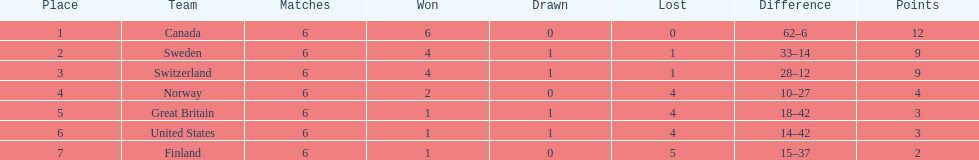What is the number of teams that achieved 6 victories? 1. 